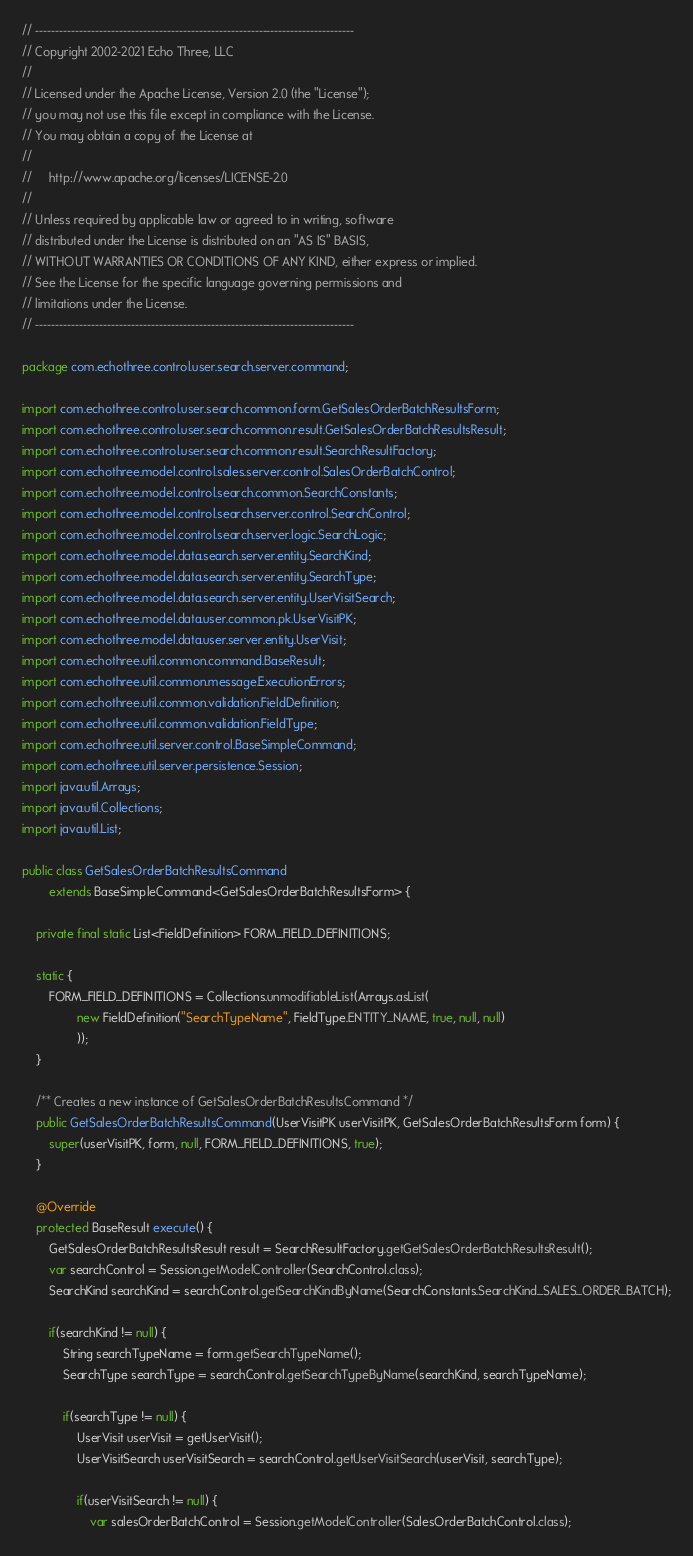Convert code to text. <code><loc_0><loc_0><loc_500><loc_500><_Java_>// --------------------------------------------------------------------------------
// Copyright 2002-2021 Echo Three, LLC
//
// Licensed under the Apache License, Version 2.0 (the "License");
// you may not use this file except in compliance with the License.
// You may obtain a copy of the License at
//
//     http://www.apache.org/licenses/LICENSE-2.0
//
// Unless required by applicable law or agreed to in writing, software
// distributed under the License is distributed on an "AS IS" BASIS,
// WITHOUT WARRANTIES OR CONDITIONS OF ANY KIND, either express or implied.
// See the License for the specific language governing permissions and
// limitations under the License.
// --------------------------------------------------------------------------------

package com.echothree.control.user.search.server.command;

import com.echothree.control.user.search.common.form.GetSalesOrderBatchResultsForm;
import com.echothree.control.user.search.common.result.GetSalesOrderBatchResultsResult;
import com.echothree.control.user.search.common.result.SearchResultFactory;
import com.echothree.model.control.sales.server.control.SalesOrderBatchControl;
import com.echothree.model.control.search.common.SearchConstants;
import com.echothree.model.control.search.server.control.SearchControl;
import com.echothree.model.control.search.server.logic.SearchLogic;
import com.echothree.model.data.search.server.entity.SearchKind;
import com.echothree.model.data.search.server.entity.SearchType;
import com.echothree.model.data.search.server.entity.UserVisitSearch;
import com.echothree.model.data.user.common.pk.UserVisitPK;
import com.echothree.model.data.user.server.entity.UserVisit;
import com.echothree.util.common.command.BaseResult;
import com.echothree.util.common.message.ExecutionErrors;
import com.echothree.util.common.validation.FieldDefinition;
import com.echothree.util.common.validation.FieldType;
import com.echothree.util.server.control.BaseSimpleCommand;
import com.echothree.util.server.persistence.Session;
import java.util.Arrays;
import java.util.Collections;
import java.util.List;

public class GetSalesOrderBatchResultsCommand
        extends BaseSimpleCommand<GetSalesOrderBatchResultsForm> {
    
    private final static List<FieldDefinition> FORM_FIELD_DEFINITIONS;

    static {
        FORM_FIELD_DEFINITIONS = Collections.unmodifiableList(Arrays.asList(
                new FieldDefinition("SearchTypeName", FieldType.ENTITY_NAME, true, null, null)
                ));
    }

    /** Creates a new instance of GetSalesOrderBatchResultsCommand */
    public GetSalesOrderBatchResultsCommand(UserVisitPK userVisitPK, GetSalesOrderBatchResultsForm form) {
        super(userVisitPK, form, null, FORM_FIELD_DEFINITIONS, true);
    }
    
    @Override
    protected BaseResult execute() {
        GetSalesOrderBatchResultsResult result = SearchResultFactory.getGetSalesOrderBatchResultsResult();
        var searchControl = Session.getModelController(SearchControl.class);
        SearchKind searchKind = searchControl.getSearchKindByName(SearchConstants.SearchKind_SALES_ORDER_BATCH);
        
        if(searchKind != null) {
            String searchTypeName = form.getSearchTypeName();
            SearchType searchType = searchControl.getSearchTypeByName(searchKind, searchTypeName);
            
            if(searchType != null) {
                UserVisit userVisit = getUserVisit();
                UserVisitSearch userVisitSearch = searchControl.getUserVisitSearch(userVisit, searchType);
                
                if(userVisitSearch != null) {
                    var salesOrderBatchControl = Session.getModelController(SalesOrderBatchControl.class);
</code> 